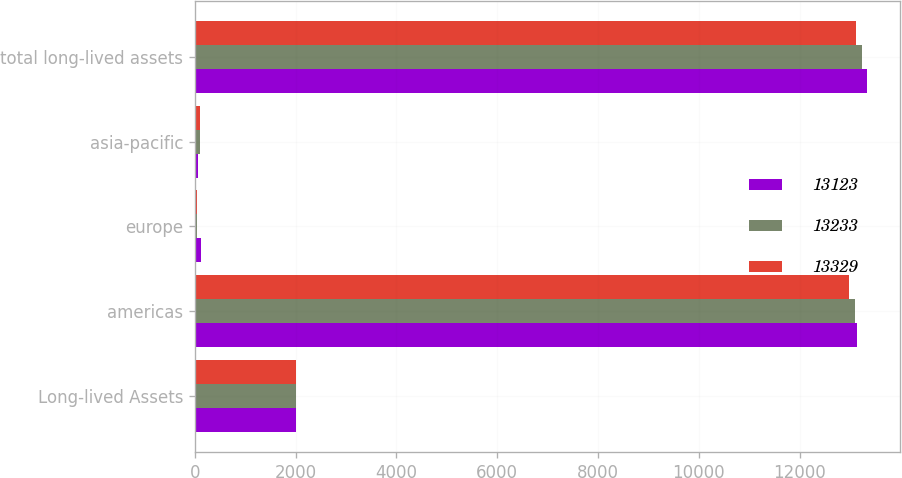<chart> <loc_0><loc_0><loc_500><loc_500><stacked_bar_chart><ecel><fcel>Long-lived Assets<fcel>americas<fcel>europe<fcel>asia-pacific<fcel>total long-lived assets<nl><fcel>13123<fcel>2011<fcel>13133<fcel>123<fcel>73<fcel>13329<nl><fcel>13233<fcel>2010<fcel>13092<fcel>42<fcel>99<fcel>13233<nl><fcel>13329<fcel>2009<fcel>12983<fcel>46<fcel>94<fcel>13123<nl></chart> 